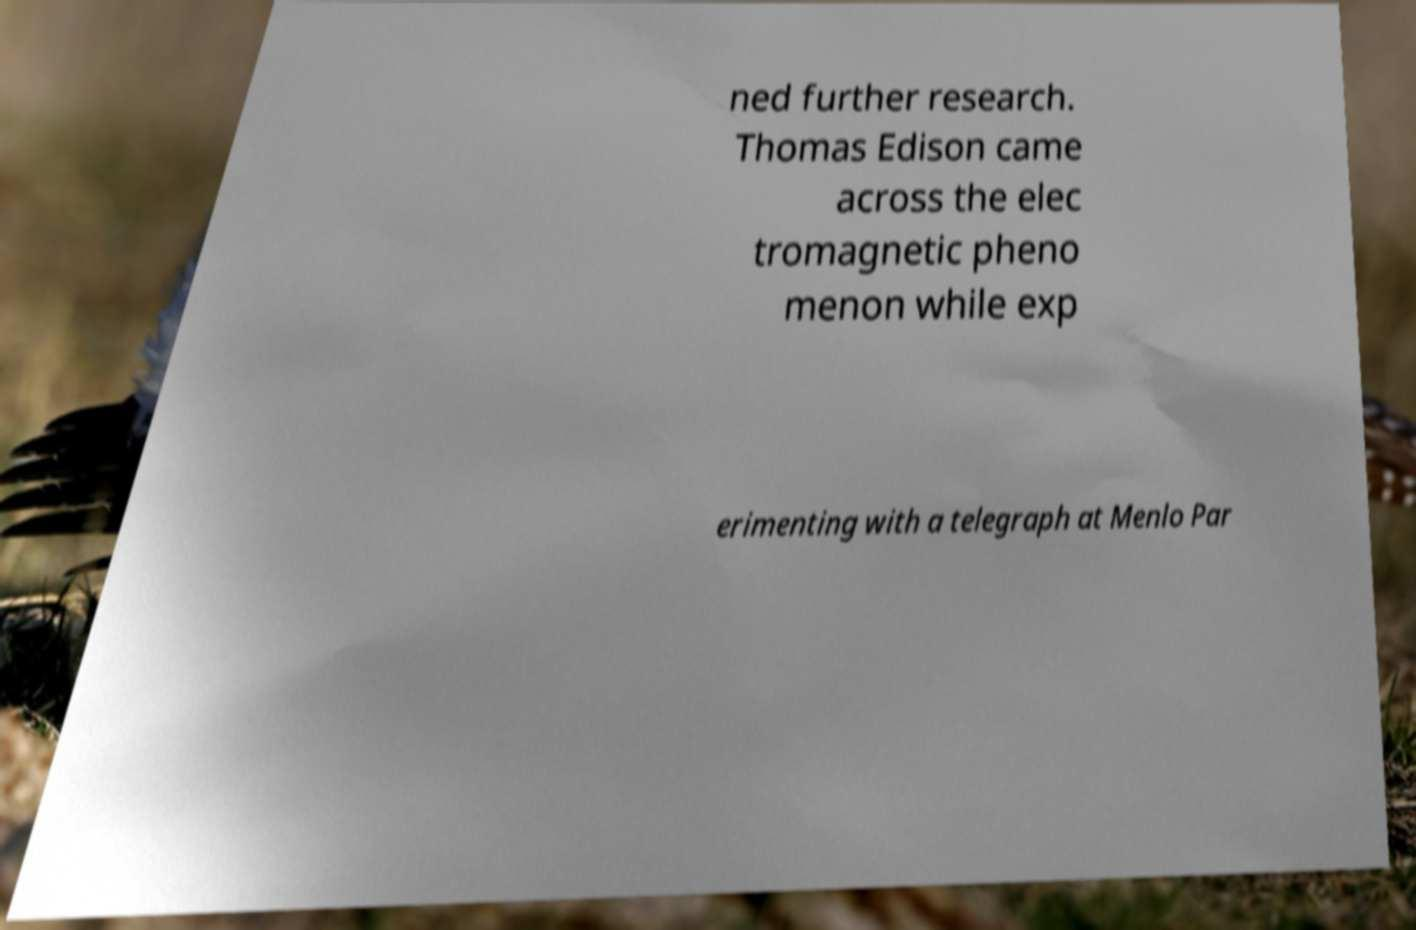For documentation purposes, I need the text within this image transcribed. Could you provide that? ned further research. Thomas Edison came across the elec tromagnetic pheno menon while exp erimenting with a telegraph at Menlo Par 